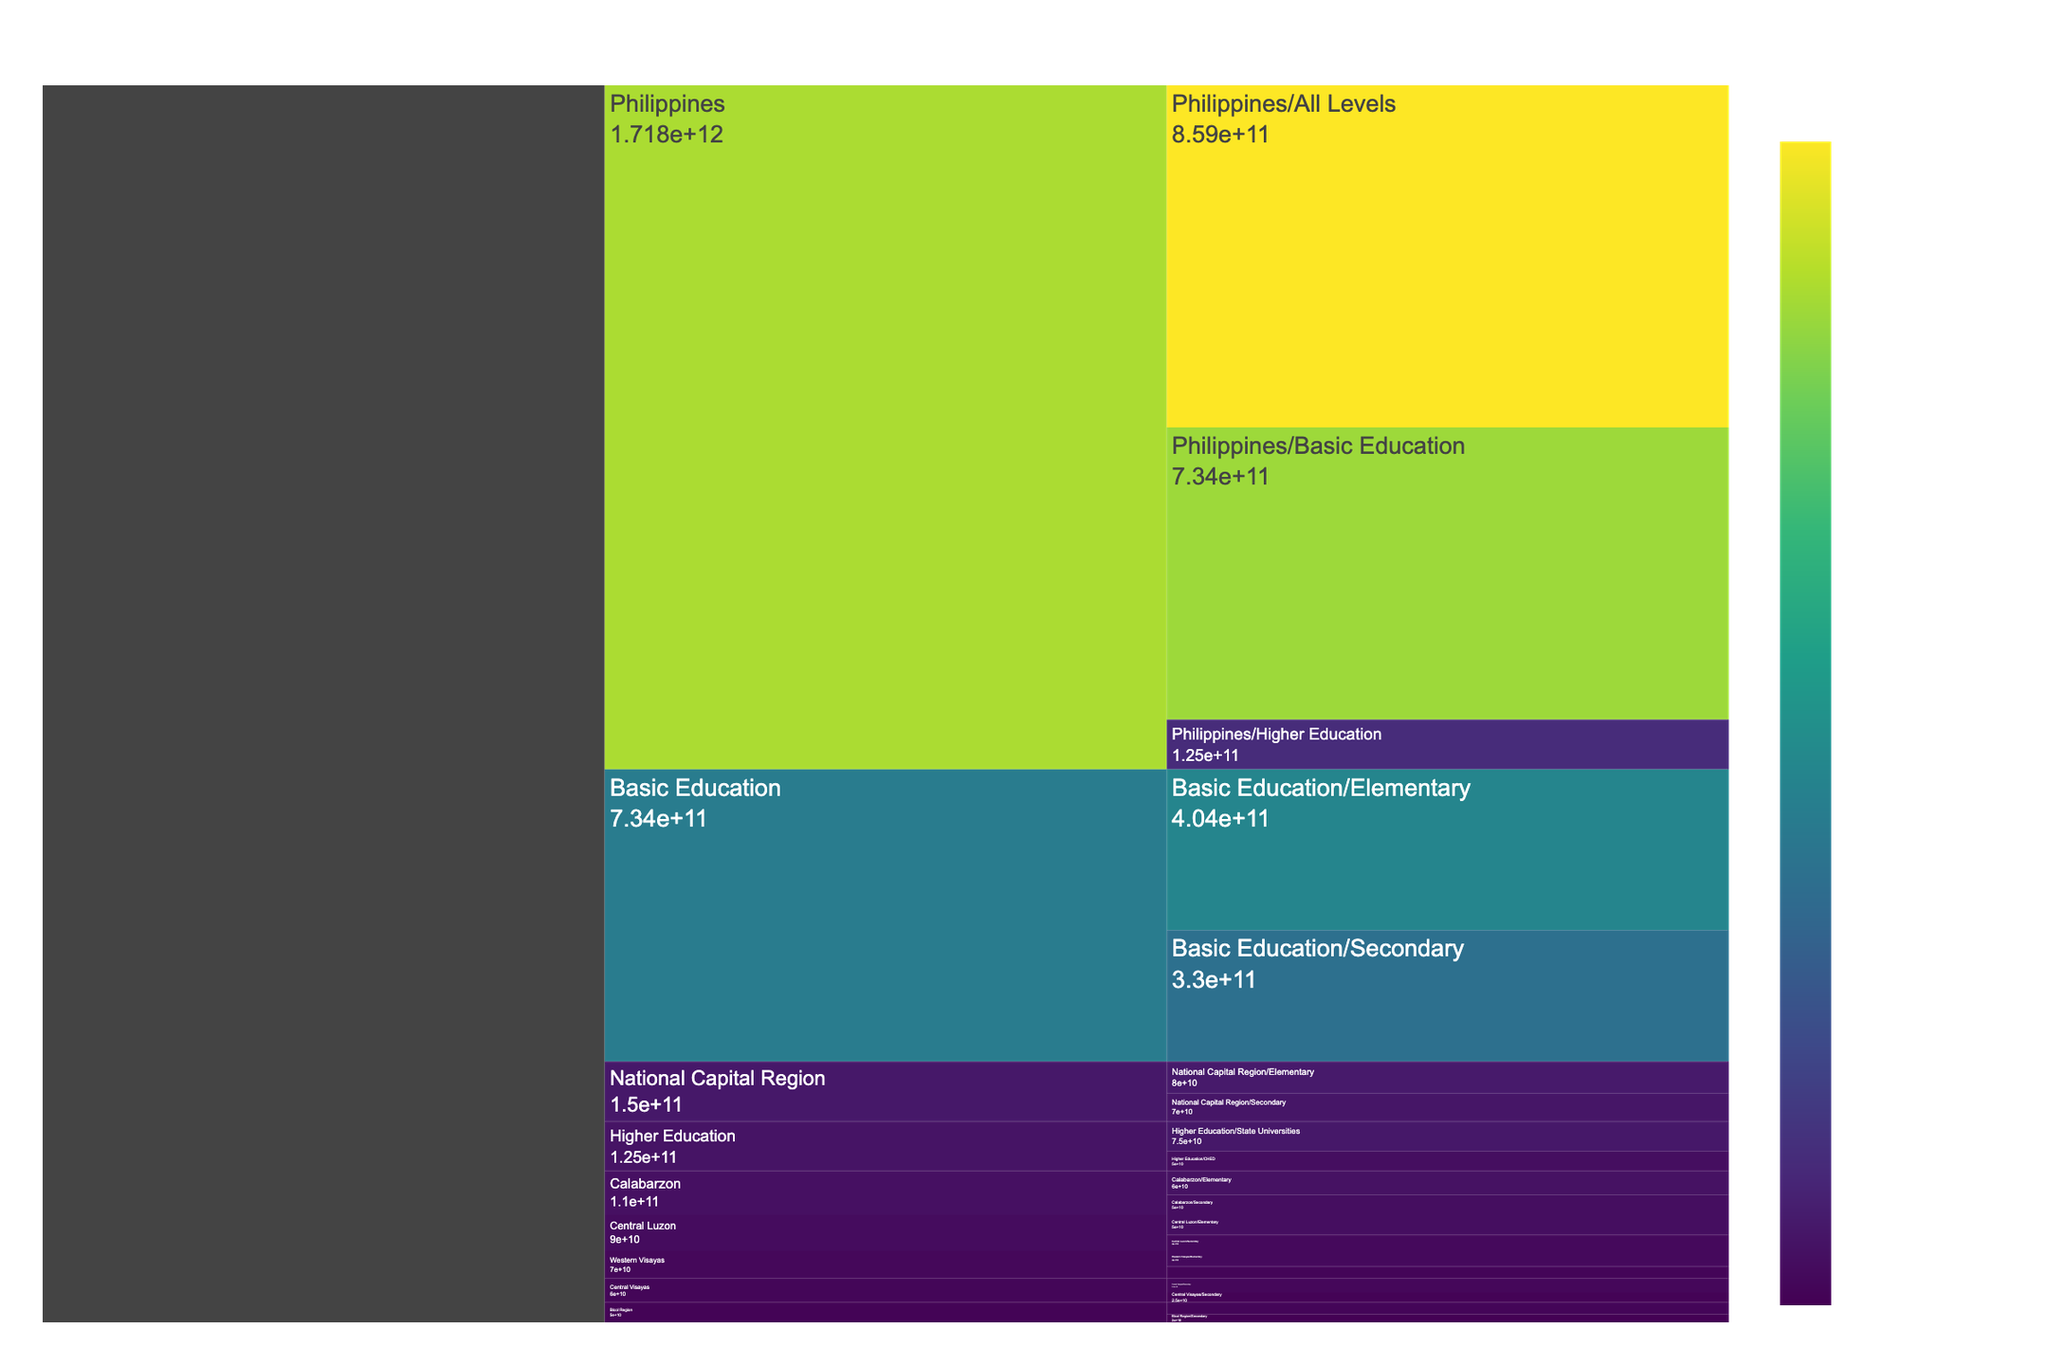What's the title of the figure? The title is prominently displayed at the top of the figure and is usually in a larger font size than other text. It provides a summary of the content or the data represented in the chart.
Answer: Educational Budget Allocation in the Philippines Which region gets the highest budget allocation for elementary education? By examining the 'Elementary' sections under each region in the icicle chart, you can compare the budget amounts. The region with the largest amount for elementary education will be the one with the brightest/largest section in the 'Elementary' category.
Answer: National Capital Region What is the total budget allocation for higher education in the Philippines? Look for the 'Higher Education' section in the icicle chart and check the value displayed. The figure should show the cumulative allocation for higher education, including both state universities and CHED.
Answer: ₱125,000,000,000 How does the budget for CHED compare to that of state universities? Identify the sections corresponding to 'CHED' and 'State Universities' under 'Higher Education.' Compare their budget allocations, which can be clearly seen in the icicle chart.
Answer: CHED receives less budget than State Universities What percentage of the total educational budget is allocated to higher education? First, find the total educational budget allocation in the 'Philippines/All Levels' section. Then, find the allocation for 'Higher Education.' Use the formula (higher education budget / total budget) * 100 to get the percentage.
Answer: 14.55% Which region has the lowest budget allocation for secondary education? Compare the 'Secondary' sections under all regions presented in the icicle chart. The region with the smallest visible section or the lowest value displayed has the lowest budget allocation.
Answer: Bicol Region How much more budget is allocated to basic education compared to higher education? Find the budget allocations for 'Basic Education' and 'Higher Education.' Subtract the higher education budget from the basic education budget to get the difference.
Answer: ₱609,000,000,000 What is the budget allocation for secondary education in Central Luzon? Locate the 'Central Luzon/Secondary' section in the icicle chart and check the budget amount displayed.
Answer: ₱40,000,000,000 Which level of education receives the highest budget in the Philippines? By looking at the different educational levels under the 'Philippines' section, compare their budget allocations. The level with the largest and most prominently colored section is the one that receives the highest budget.
Answer: Basic Education 